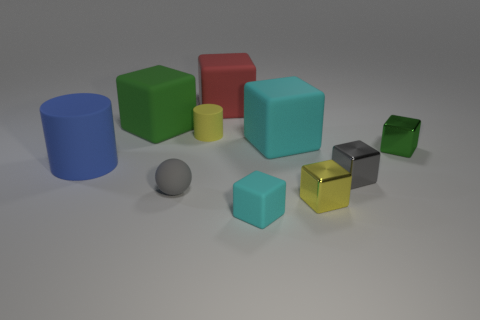Subtract 2 blocks. How many blocks are left? 5 Subtract all green shiny cubes. How many cubes are left? 6 Subtract all cyan cubes. How many cubes are left? 5 Subtract all red blocks. Subtract all cyan cylinders. How many blocks are left? 6 Subtract all blocks. How many objects are left? 3 Subtract all tiny red matte spheres. Subtract all gray shiny cubes. How many objects are left? 9 Add 6 tiny cubes. How many tiny cubes are left? 10 Add 9 small yellow matte spheres. How many small yellow matte spheres exist? 9 Subtract 0 purple cylinders. How many objects are left? 10 